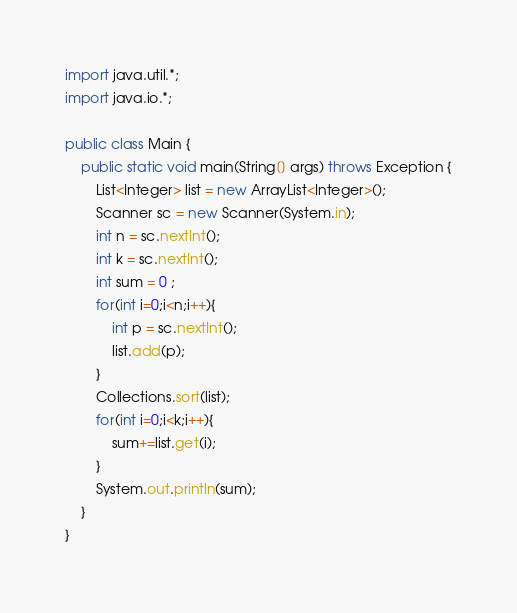<code> <loc_0><loc_0><loc_500><loc_500><_Java_>import java.util.*;
import java.io.*;

public class Main {
    public static void main(String[] args) throws Exception {
        List<Integer> list = new ArrayList<Integer>();
        Scanner sc = new Scanner(System.in);
        int n = sc.nextInt();
        int k = sc.nextInt();
        int sum = 0 ;
        for(int i=0;i<n;i++){
            int p = sc.nextInt();
            list.add(p);
        }
        Collections.sort(list);
        for(int i=0;i<k;i++){
            sum+=list.get(i);
        }
        System.out.println(sum);
    }
}</code> 